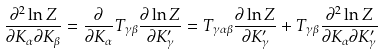<formula> <loc_0><loc_0><loc_500><loc_500>\frac { \partial ^ { 2 } \ln Z } { \partial K _ { \alpha } \partial K _ { \beta } } = \frac { \partial } { \partial K _ { \alpha } } T _ { \gamma \beta } \frac { \partial \ln Z } { \partial K _ { \gamma } ^ { \prime } } = T _ { \gamma \alpha \beta } \frac { \partial \ln Z } { \partial K _ { \gamma } ^ { \prime } } + T _ { \gamma \beta } \frac { \partial ^ { 2 } \ln Z } { \partial K _ { \alpha } \partial K _ { \gamma } ^ { \prime } }</formula> 